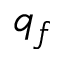Convert formula to latex. <formula><loc_0><loc_0><loc_500><loc_500>q _ { f }</formula> 